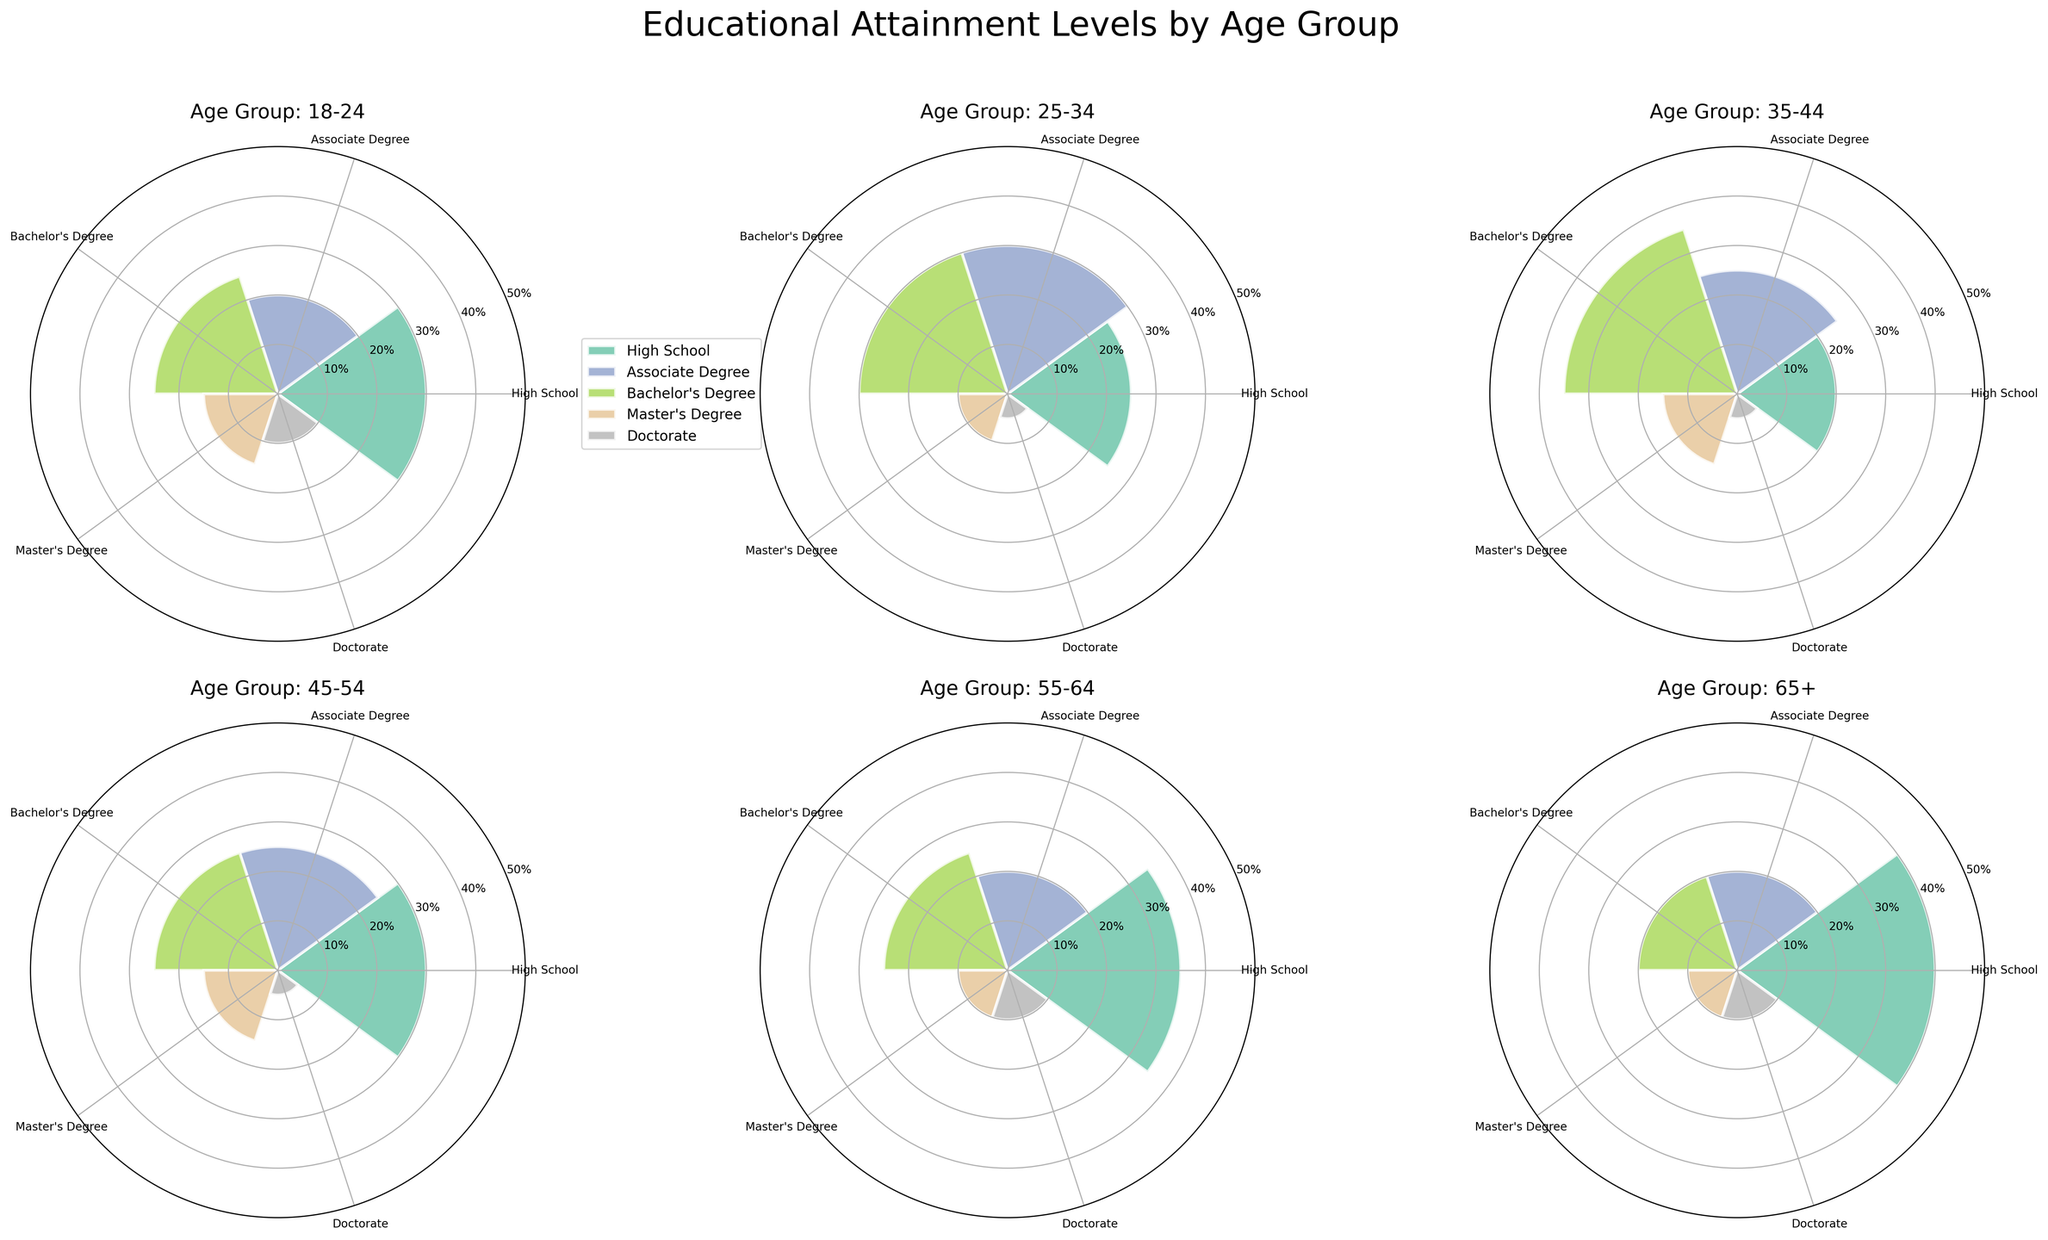What's the title of the figure? The title of the figure is prominently displayed at the top of the figure. It reads "Educational Attainment Levels by Age Group".
Answer: Educational Attainment Levels by Age Group Which education level category in the 18-24 age group has the highest percentage? In the subplot titled "Age Group: 18-24", the Bachelor's Degree category has the highest percentage, shown as the largest bar.
Answer: Bachelor's Degree What is the percentage of Master's Degrees in the 25-34 age group? In the subplot titled "Age Group: 25-34", the Master's Degree bar reaches the 10% mark on the radial axis.
Answer: 10% How does the percentage of Doctorates in the 45-54 age group compare to that of the 55-64 age group? By inspecting the subplots for ages 45-54 and 55-64, the percentage of Doctorates for both groups is found to be the same, as both bars reach the 5% mark.
Answer: Equal What is the average percentage of High School education across all age groups? To calculate the average, sum the percentages of High School education for all age groups: 30% + 25% + 20% + 30% + 35% + 40% = 180%. Then divide by 6 (the number of age groups): 180% / 6 = 30%.
Answer: 30% Which age group has the highest percentage of individuals with a High School education? In the subplot for the age group 65+, the High School education bar reaches the 40% mark, which is higher than in any other age group.
Answer: 65+ Compare the percentages of Bachelor's Degree holders between the 18-24 and 35-44 age groups. Which age group has a higher percentage? The subplot for the 18-24 age group shows the Bachelor's Degree percentage at 25%, while the subplot for the 35-44 age group shows it at 35%. Thus, the 35-44 age group has a higher percentage.
Answer: 35-44 What is the total percentage of people with at least an Associate Degree in the 55-64 age group? Sum the percentages for Associate Degree, Bachelor's Degree, Master's Degree, and Doctorate in the 55-64 age group: 20% + 25% + 10% + 10% = 65%.
Answer: 65% In which age group is the proportion of individuals with an Associate Degree the highest? By observing all subplots, the 25-34 age group has the highest bar for Associate Degree, reaching the 30% mark.
Answer: 25-34 